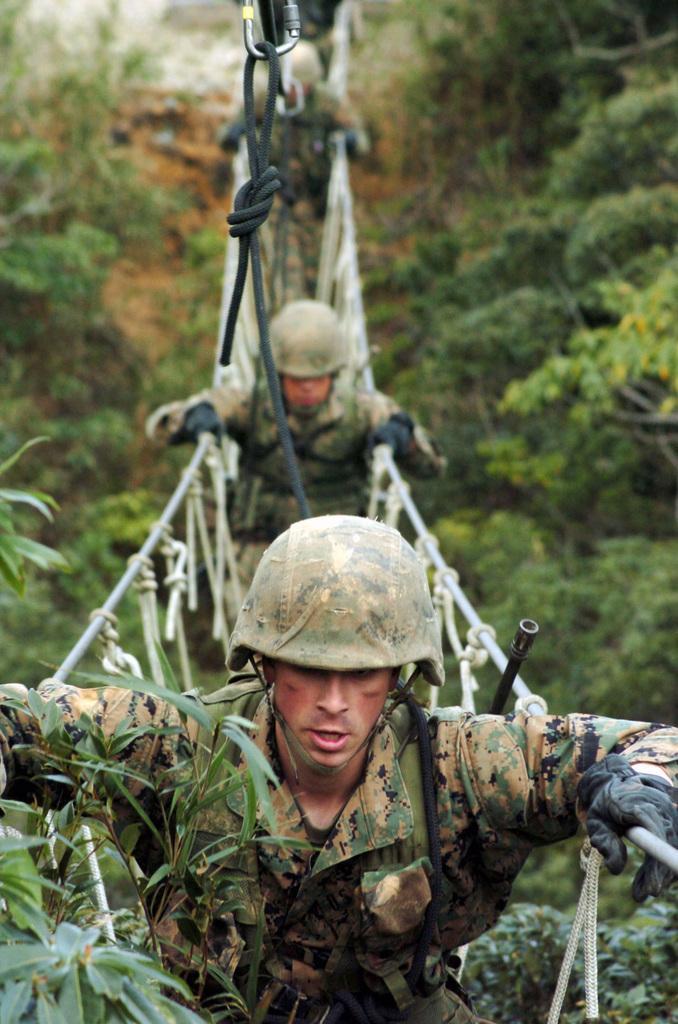Please provide a concise description of this image. In this image I can see a bridge in the center and on it I can see few people are standing. I can see they all are wearing uniforms, gloves and helmets. Both side of this bridge I can see number of trees and I can see this image is little bit blurry in the background. 